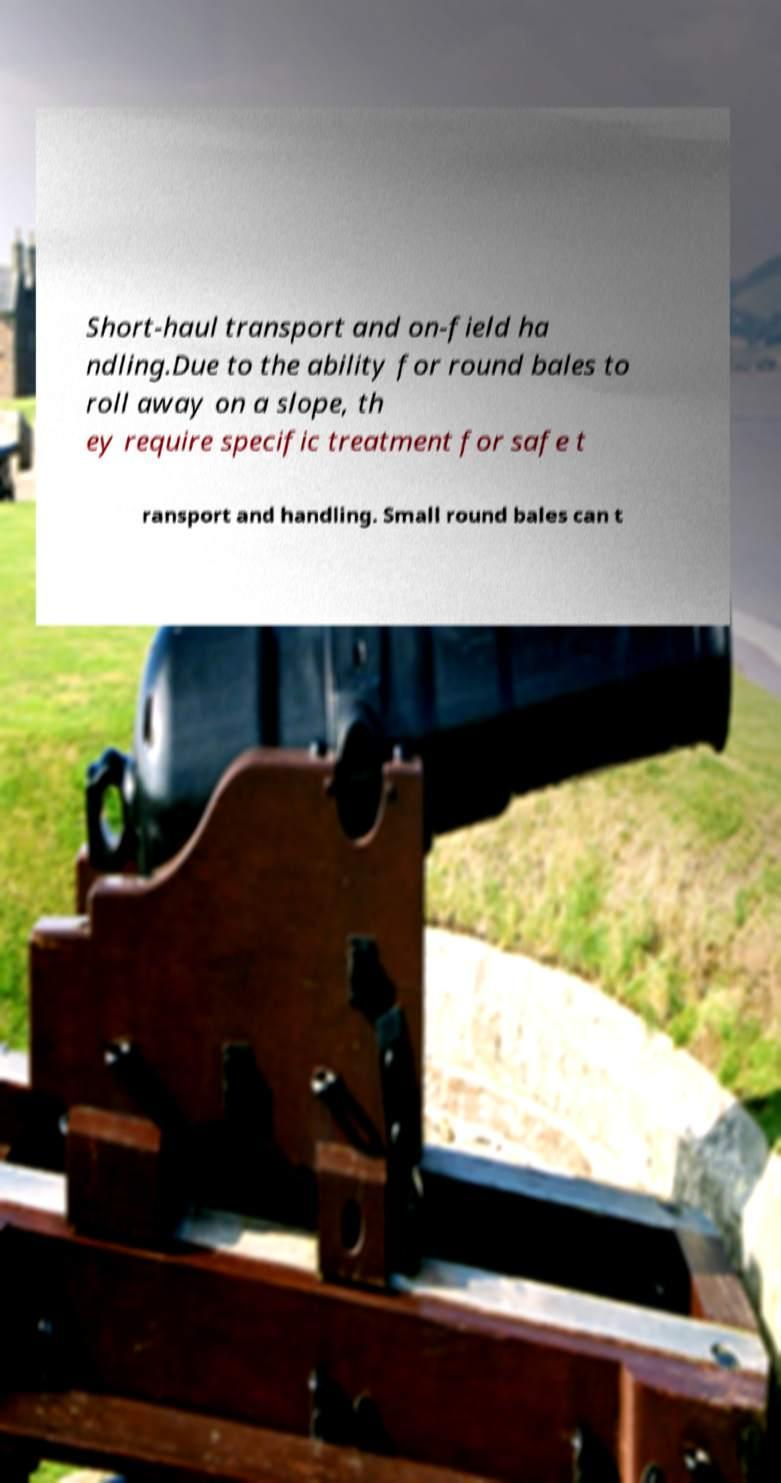Could you extract and type out the text from this image? Short-haul transport and on-field ha ndling.Due to the ability for round bales to roll away on a slope, th ey require specific treatment for safe t ransport and handling. Small round bales can t 